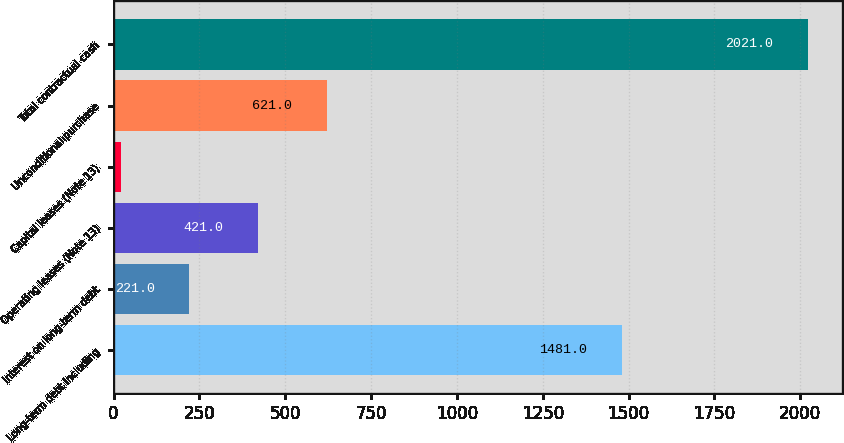Convert chart. <chart><loc_0><loc_0><loc_500><loc_500><bar_chart><fcel>Long-term debt including<fcel>Interest on long-term debt<fcel>Operating leases (Note 13)<fcel>Capital leases (Note 13)<fcel>Unconditional purchase<fcel>Total contractual cash<nl><fcel>1481<fcel>221<fcel>421<fcel>21<fcel>621<fcel>2021<nl></chart> 